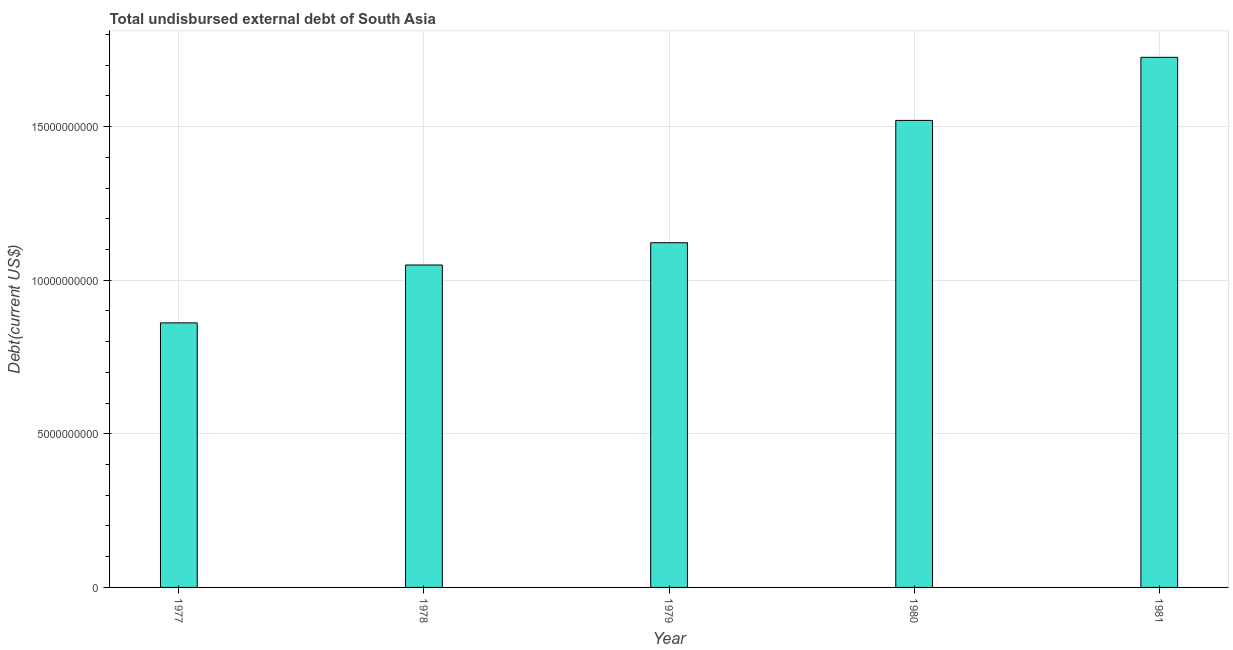What is the title of the graph?
Provide a short and direct response. Total undisbursed external debt of South Asia. What is the label or title of the X-axis?
Provide a short and direct response. Year. What is the label or title of the Y-axis?
Your response must be concise. Debt(current US$). What is the total debt in 1980?
Give a very brief answer. 1.52e+1. Across all years, what is the maximum total debt?
Your answer should be very brief. 1.73e+1. Across all years, what is the minimum total debt?
Give a very brief answer. 8.61e+09. In which year was the total debt maximum?
Make the answer very short. 1981. What is the sum of the total debt?
Your response must be concise. 6.28e+1. What is the difference between the total debt in 1977 and 1980?
Your answer should be very brief. -6.59e+09. What is the average total debt per year?
Give a very brief answer. 1.26e+1. What is the median total debt?
Keep it short and to the point. 1.12e+1. What is the ratio of the total debt in 1978 to that in 1980?
Offer a terse response. 0.69. Is the difference between the total debt in 1977 and 1978 greater than the difference between any two years?
Your answer should be compact. No. What is the difference between the highest and the second highest total debt?
Make the answer very short. 2.05e+09. What is the difference between the highest and the lowest total debt?
Your answer should be very brief. 8.64e+09. How many bars are there?
Give a very brief answer. 5. Are all the bars in the graph horizontal?
Keep it short and to the point. No. What is the difference between two consecutive major ticks on the Y-axis?
Provide a short and direct response. 5.00e+09. Are the values on the major ticks of Y-axis written in scientific E-notation?
Provide a succinct answer. No. What is the Debt(current US$) of 1977?
Your response must be concise. 8.61e+09. What is the Debt(current US$) in 1978?
Your answer should be very brief. 1.05e+1. What is the Debt(current US$) of 1979?
Ensure brevity in your answer.  1.12e+1. What is the Debt(current US$) of 1980?
Your answer should be very brief. 1.52e+1. What is the Debt(current US$) of 1981?
Make the answer very short. 1.73e+1. What is the difference between the Debt(current US$) in 1977 and 1978?
Give a very brief answer. -1.88e+09. What is the difference between the Debt(current US$) in 1977 and 1979?
Your answer should be compact. -2.61e+09. What is the difference between the Debt(current US$) in 1977 and 1980?
Your response must be concise. -6.59e+09. What is the difference between the Debt(current US$) in 1977 and 1981?
Offer a terse response. -8.64e+09. What is the difference between the Debt(current US$) in 1978 and 1979?
Provide a short and direct response. -7.24e+08. What is the difference between the Debt(current US$) in 1978 and 1980?
Offer a terse response. -4.71e+09. What is the difference between the Debt(current US$) in 1978 and 1981?
Ensure brevity in your answer.  -6.76e+09. What is the difference between the Debt(current US$) in 1979 and 1980?
Provide a succinct answer. -3.98e+09. What is the difference between the Debt(current US$) in 1979 and 1981?
Provide a succinct answer. -6.03e+09. What is the difference between the Debt(current US$) in 1980 and 1981?
Keep it short and to the point. -2.05e+09. What is the ratio of the Debt(current US$) in 1977 to that in 1978?
Your response must be concise. 0.82. What is the ratio of the Debt(current US$) in 1977 to that in 1979?
Offer a terse response. 0.77. What is the ratio of the Debt(current US$) in 1977 to that in 1980?
Offer a very short reply. 0.57. What is the ratio of the Debt(current US$) in 1977 to that in 1981?
Your response must be concise. 0.5. What is the ratio of the Debt(current US$) in 1978 to that in 1979?
Your answer should be compact. 0.94. What is the ratio of the Debt(current US$) in 1978 to that in 1980?
Give a very brief answer. 0.69. What is the ratio of the Debt(current US$) in 1978 to that in 1981?
Give a very brief answer. 0.61. What is the ratio of the Debt(current US$) in 1979 to that in 1980?
Your answer should be compact. 0.74. What is the ratio of the Debt(current US$) in 1979 to that in 1981?
Make the answer very short. 0.65. What is the ratio of the Debt(current US$) in 1980 to that in 1981?
Provide a succinct answer. 0.88. 